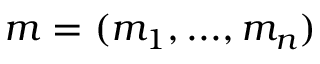<formula> <loc_0><loc_0><loc_500><loc_500>m = ( m _ { 1 } , \dots , m _ { n } )</formula> 